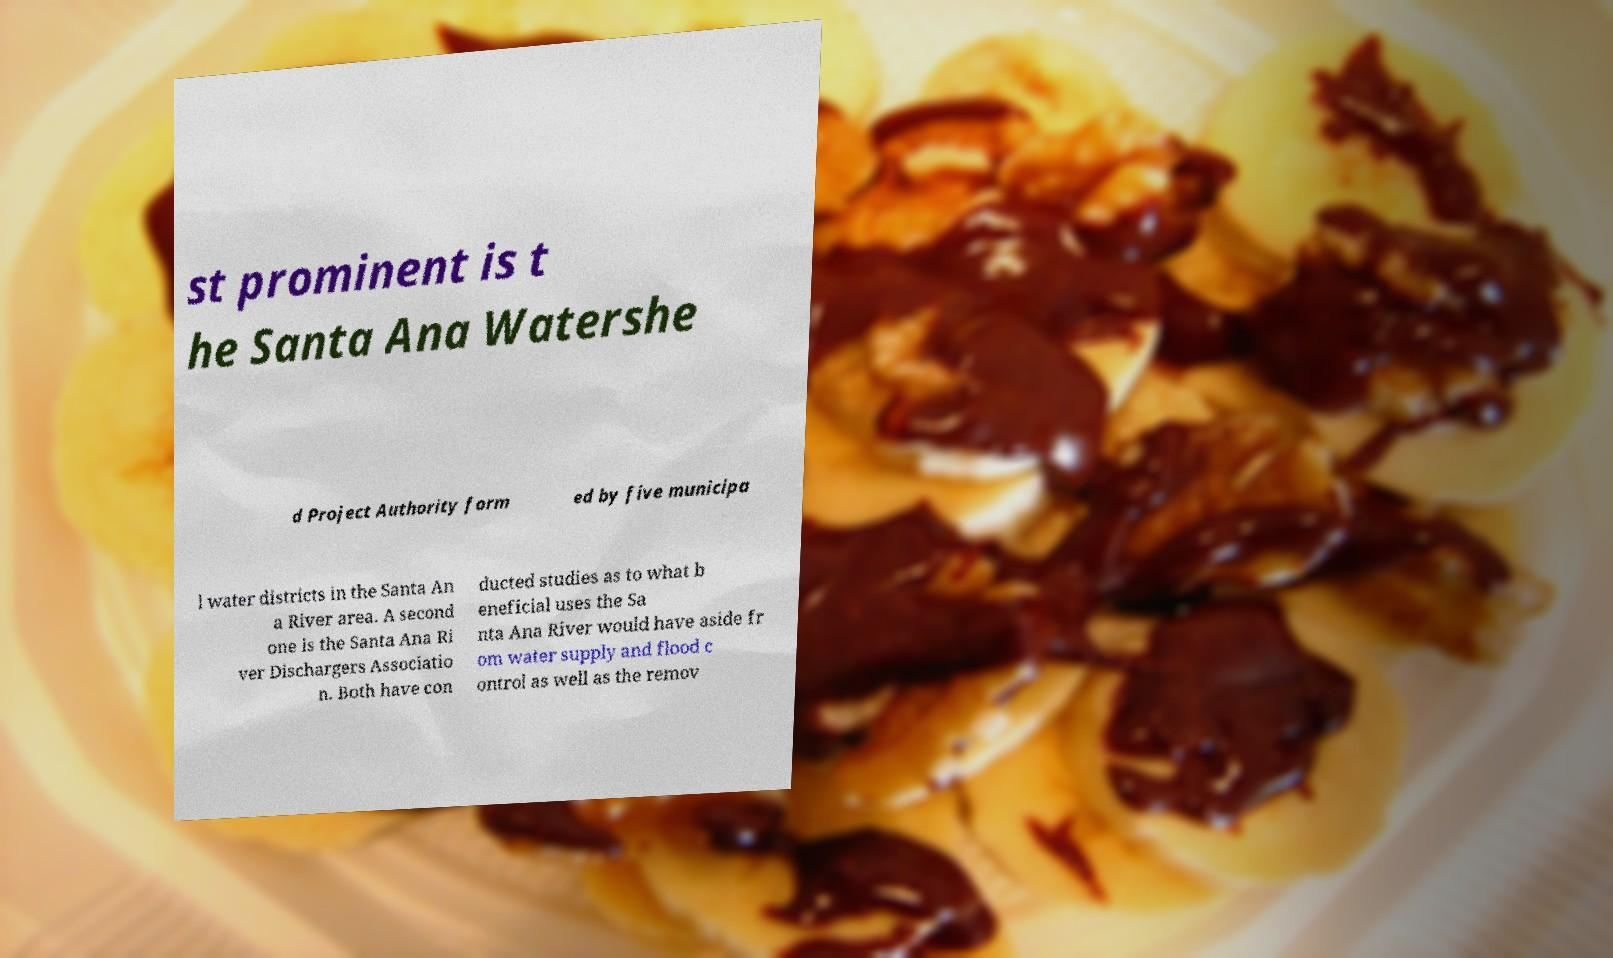I need the written content from this picture converted into text. Can you do that? st prominent is t he Santa Ana Watershe d Project Authority form ed by five municipa l water districts in the Santa An a River area. A second one is the Santa Ana Ri ver Dischargers Associatio n. Both have con ducted studies as to what b eneficial uses the Sa nta Ana River would have aside fr om water supply and flood c ontrol as well as the remov 